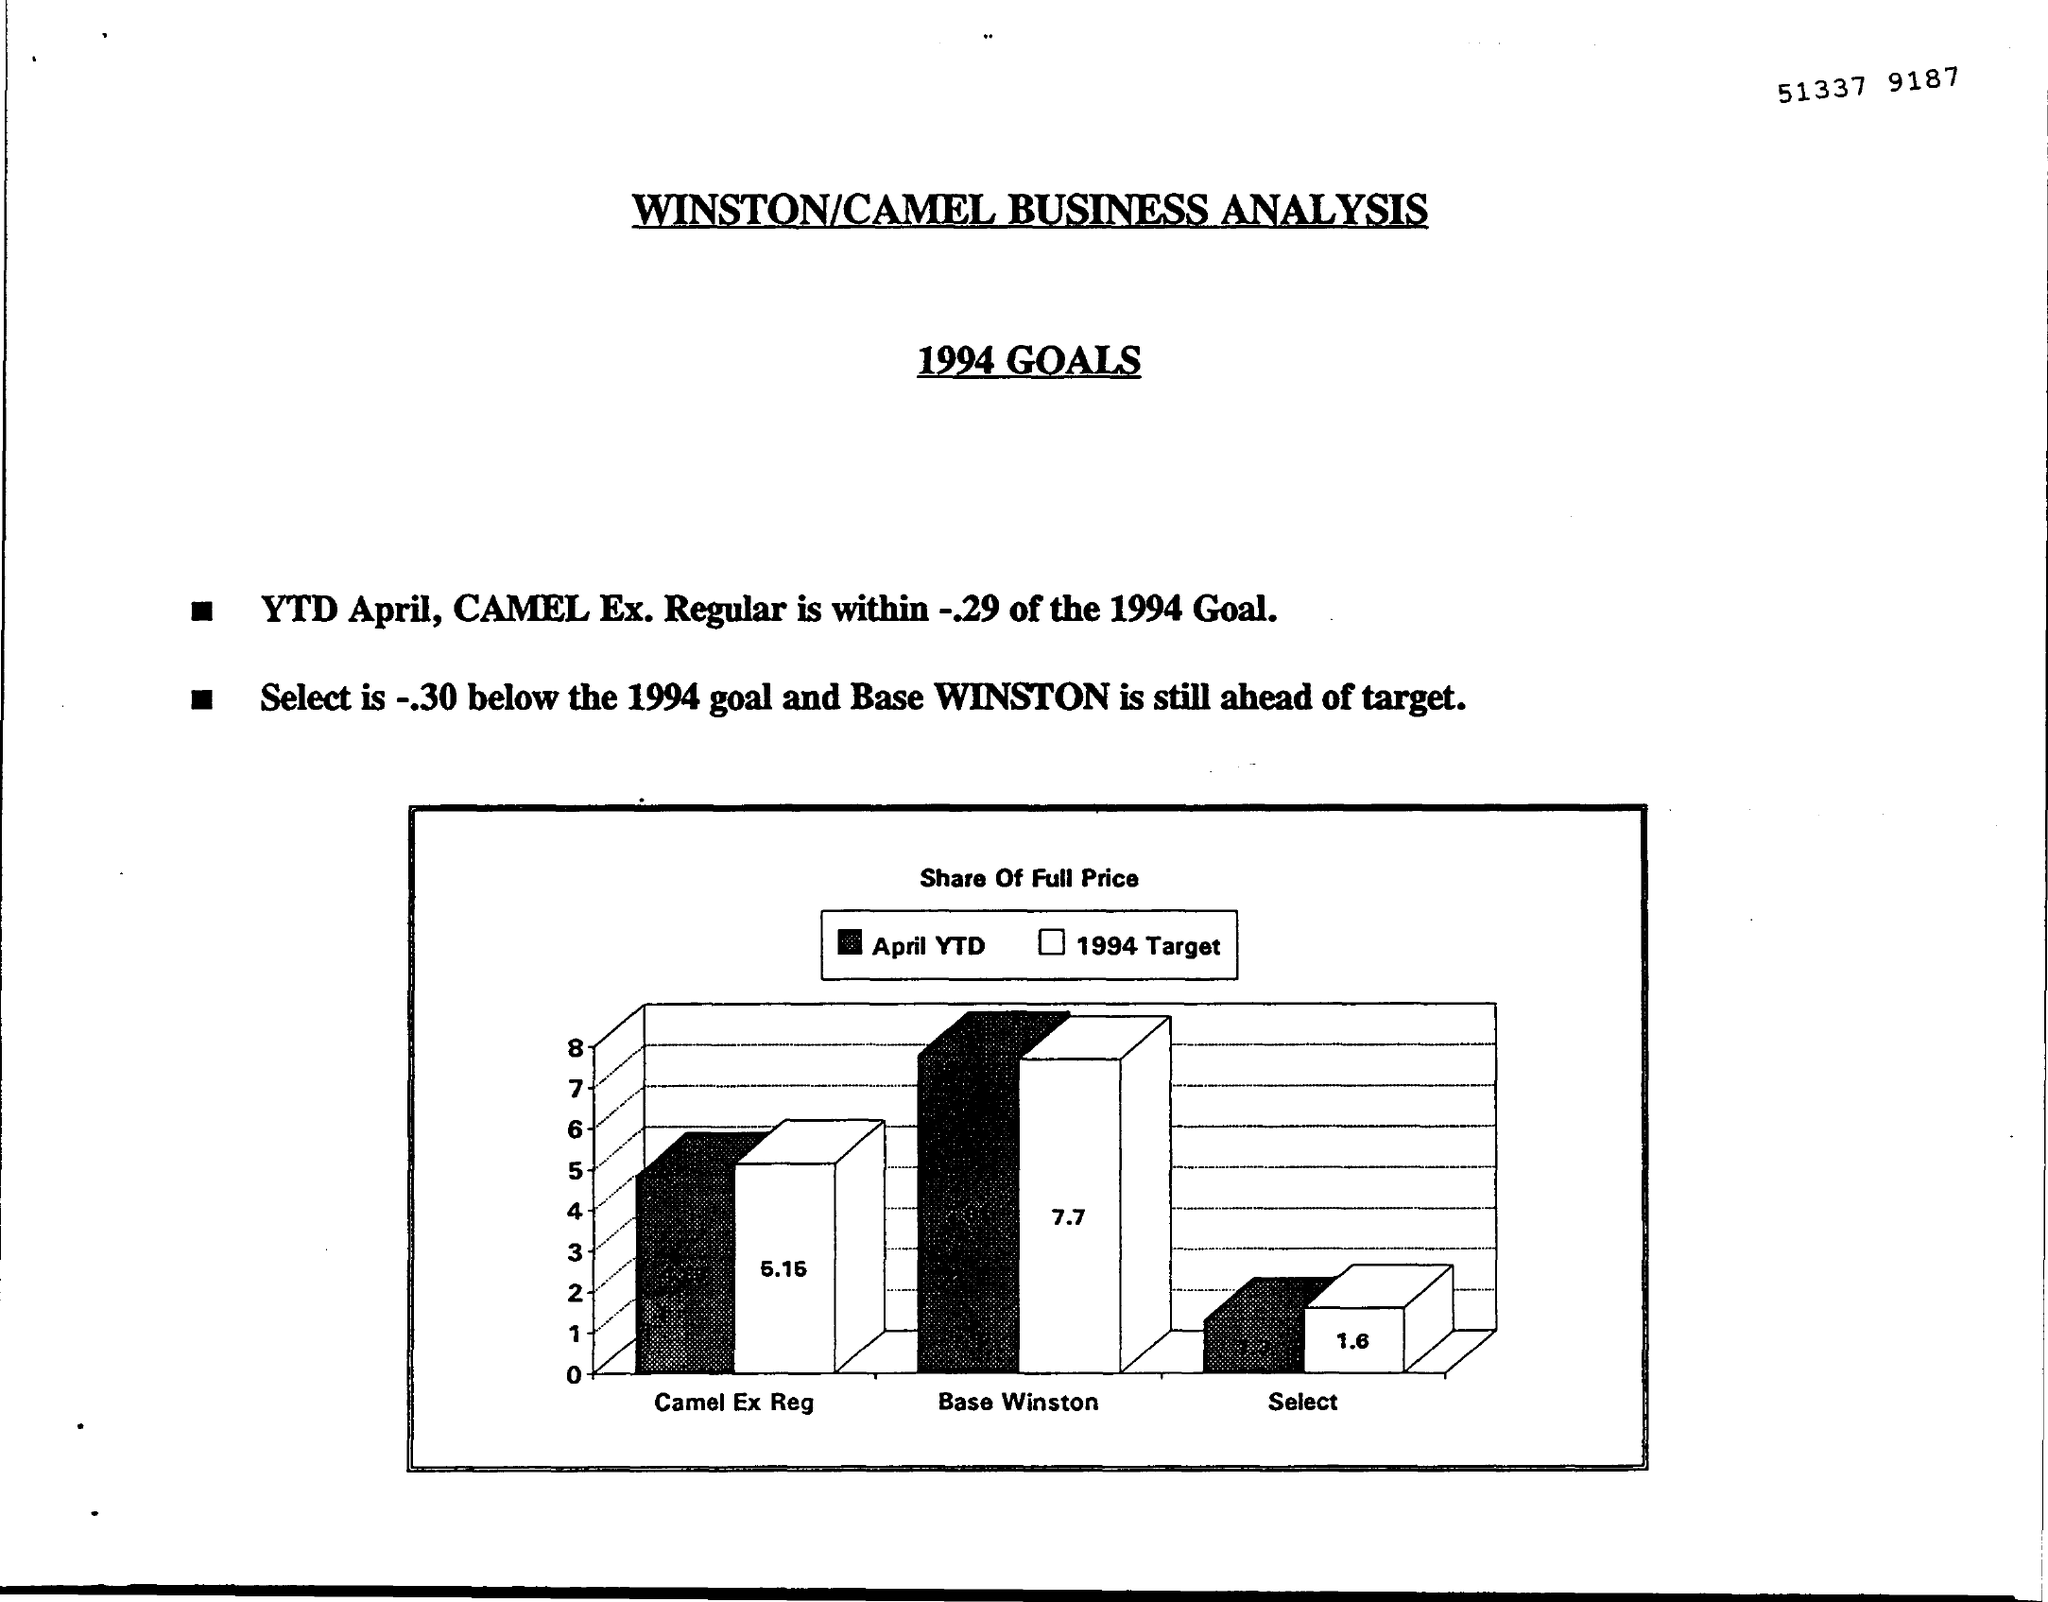What is the document title?
Ensure brevity in your answer.  WINSTON/CAMEL BUSINESS ANALYSIS. For which year are the goals?
Provide a short and direct response. 1994. What is the title of the figure?
Keep it short and to the point. Share Of Full Price. What does the white bar show?
Make the answer very short. 1994 Target. 